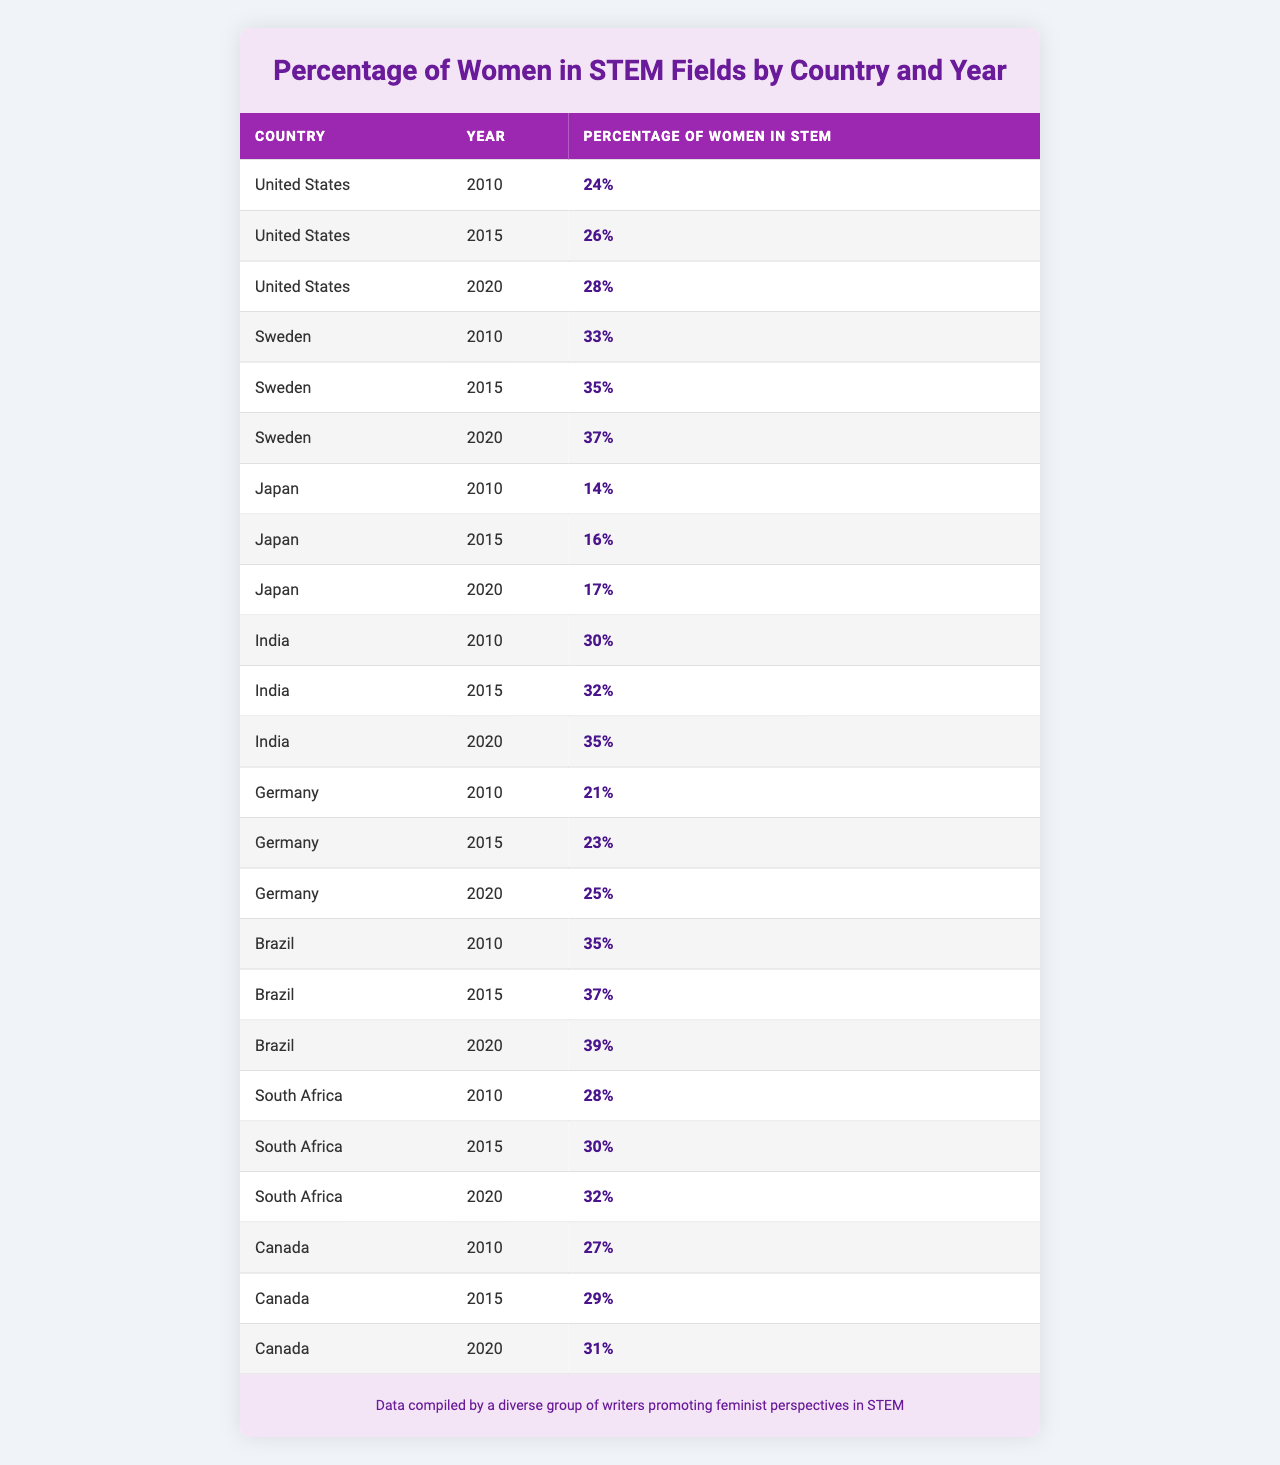What was the percentage of women in STEM in India in 2015? According to the table, the percentage of women in STEM in India for the year 2015 is listed as 32%.
Answer: 32% Which country had the highest percentage of women in STEM fields in 2020? By checking the percentages for the year 2020: United States - 28%, Sweden - 37%, Japan - 17%, India - 35%, Germany - 25%, Brazil - 39%, South Africa - 32%, and Canada - 31%. The highest is Brazil with 39%.
Answer: Brazil What was the percentage increase of women in STEM in the United States from 2010 to 2020? The percentage in the United States in 2010 was 24% and in 2020 it was 28%. The increase is calculated as 28% - 24% = 4%.
Answer: 4% Did the percentage of women in STEM in Japan increase every five years from 2010 to 2020? Reviewing the data: 2010 - 14%, 2015 - 16%, and 2020 - 17%. Each year shows an increase, confirming it increased every five years.
Answer: Yes What is the average percentage of women in STEM across all countries for the year 2015? The percentages in 2015 are: United States - 26%, Sweden - 35%, Japan - 16%, India - 32%, Germany - 23%, Brazil - 37%, South Africa - 30%, Canada - 29%. Summing these yields 26 + 35 + 16 + 32 + 23 + 37 + 30 + 29 =  258%. Dividing by the number of countries (8) gives an average of 258% / 8 = 32.25%.
Answer: 32.25% Which two countries had the same percentage of women in STEM in 2015? Checking the 2015 data, I find that the United States had 26% and Germany had 23%. None match exactly. In the data, no two countries have the same percentage for 2015.
Answer: No What was the overall trend in the percentage of women in STEM from 2010 to 2020 for Sweden? The percentages for Sweden are: 2010 - 33%, 2015 - 35%, and 2020 - 37%. Each percentage shows an upward trend, meaning the overall trend is an increase.
Answer: Increase How many percentage points did women's representation in STEM grow in Canada from 2010 to 2020? The percentage in Canada was 27% in 2010 and rose to 31% in 2020. The difference calculated is 31% - 27% = 4 percentage points.
Answer: 4 Which country had the lowest percentage of women in STEM in 2020? Looking at the percentages for 2020: United States - 28%, Sweden - 37%, Japan - 17%, India - 35%, Germany - 25%, Brazil - 39%, South Africa - 32%, and Canada - 31%, Japan has the lowest at 17%.
Answer: Japan What is the total percentage of women in STEM in South Africa from 2010 to 2020? The percentages are: 28% in 2010, 30% in 2015, and 32% in 2020. Summing these gives 28 + 30 + 32 = 90%.
Answer: 90% 